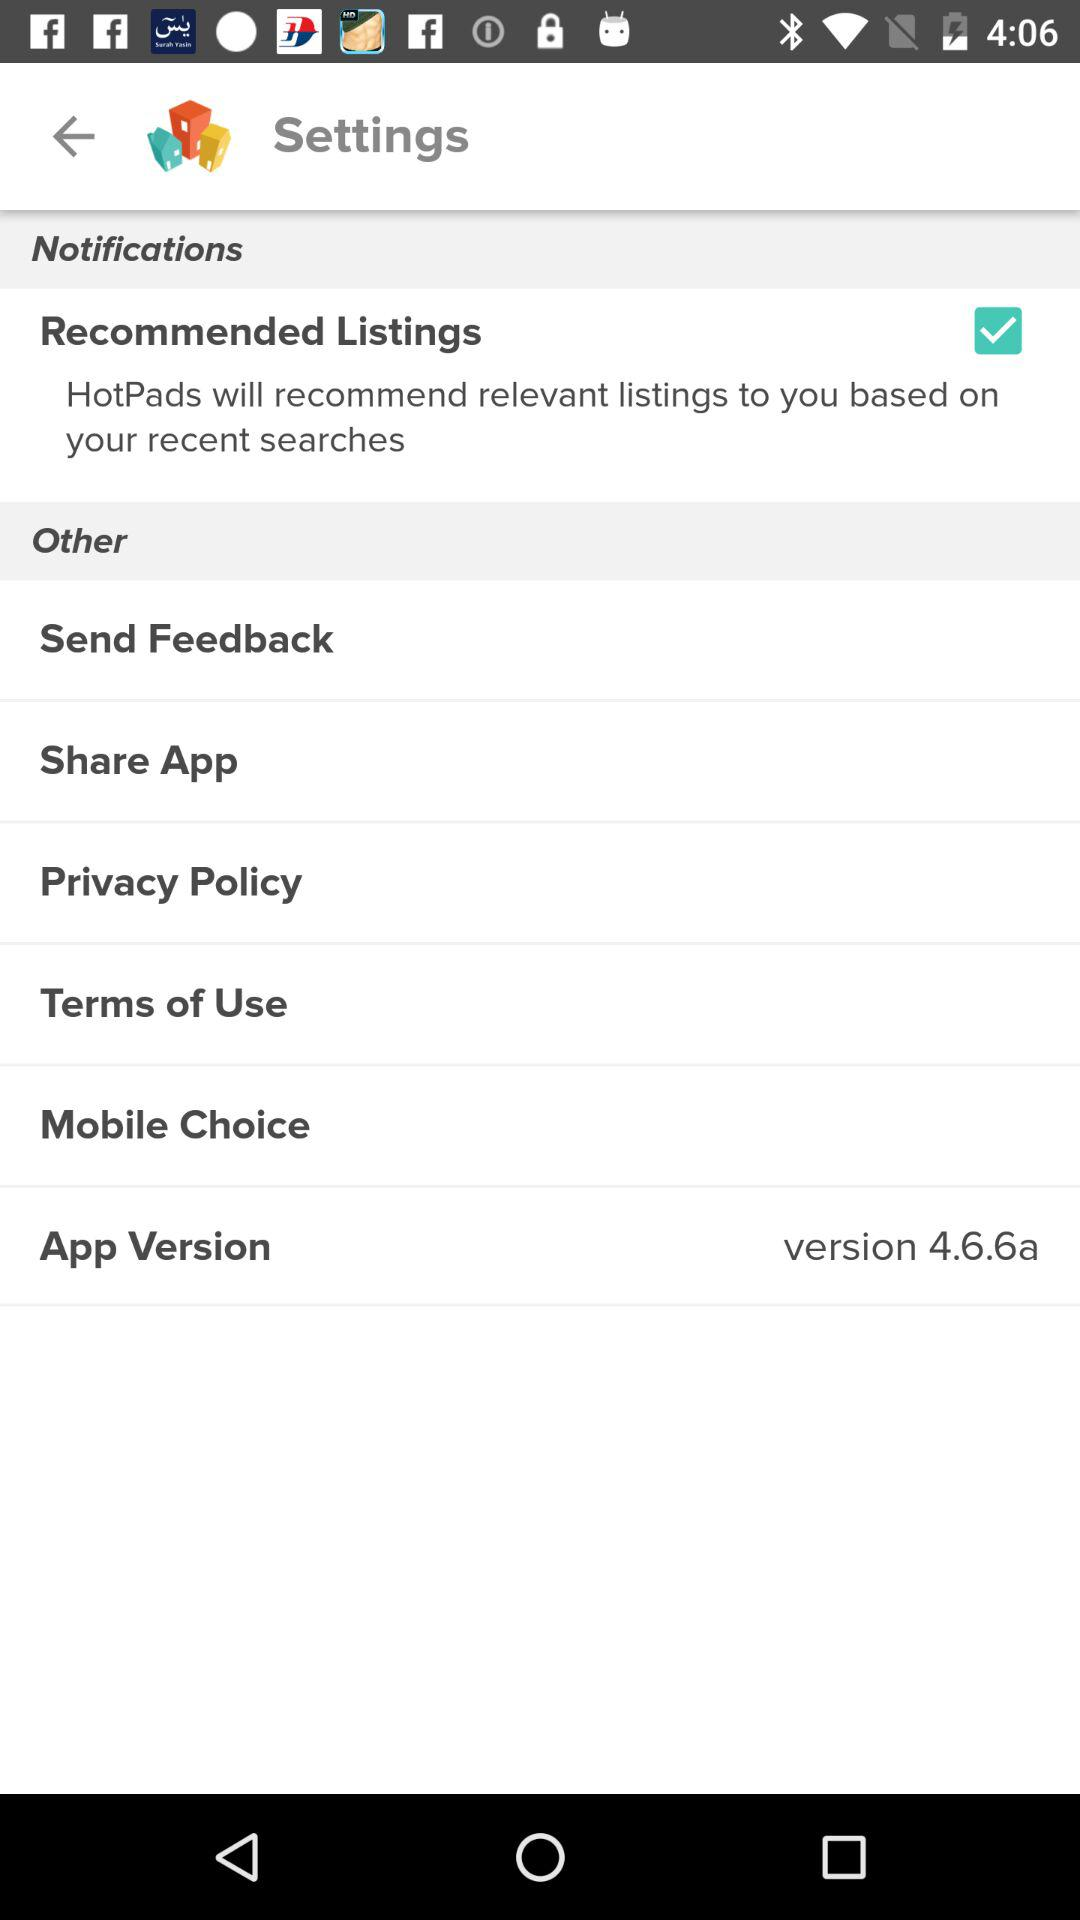What is the version of the application? The version of the application is 4.6.6a. 